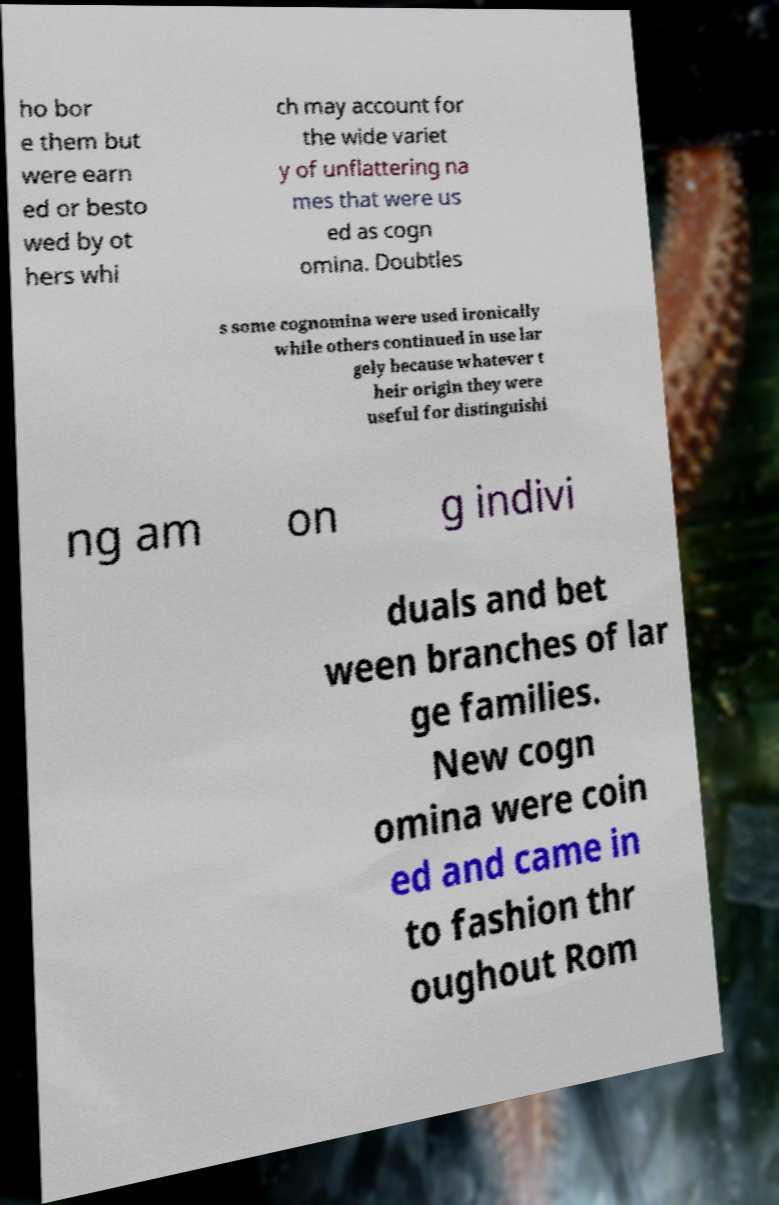Can you read and provide the text displayed in the image?This photo seems to have some interesting text. Can you extract and type it out for me? ho bor e them but were earn ed or besto wed by ot hers whi ch may account for the wide variet y of unflattering na mes that were us ed as cogn omina. Doubtles s some cognomina were used ironically while others continued in use lar gely because whatever t heir origin they were useful for distinguishi ng am on g indivi duals and bet ween branches of lar ge families. New cogn omina were coin ed and came in to fashion thr oughout Rom 